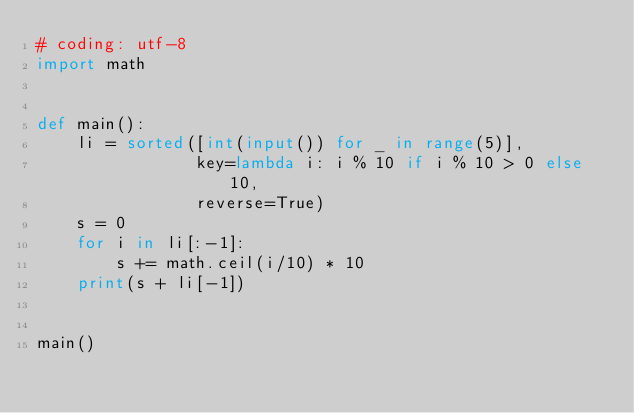Convert code to text. <code><loc_0><loc_0><loc_500><loc_500><_Python_># coding: utf-8
import math


def main():
    li = sorted([int(input()) for _ in range(5)],
                key=lambda i: i % 10 if i % 10 > 0 else 10,
                reverse=True)
    s = 0
    for i in li[:-1]:
        s += math.ceil(i/10) * 10
    print(s + li[-1])


main()</code> 